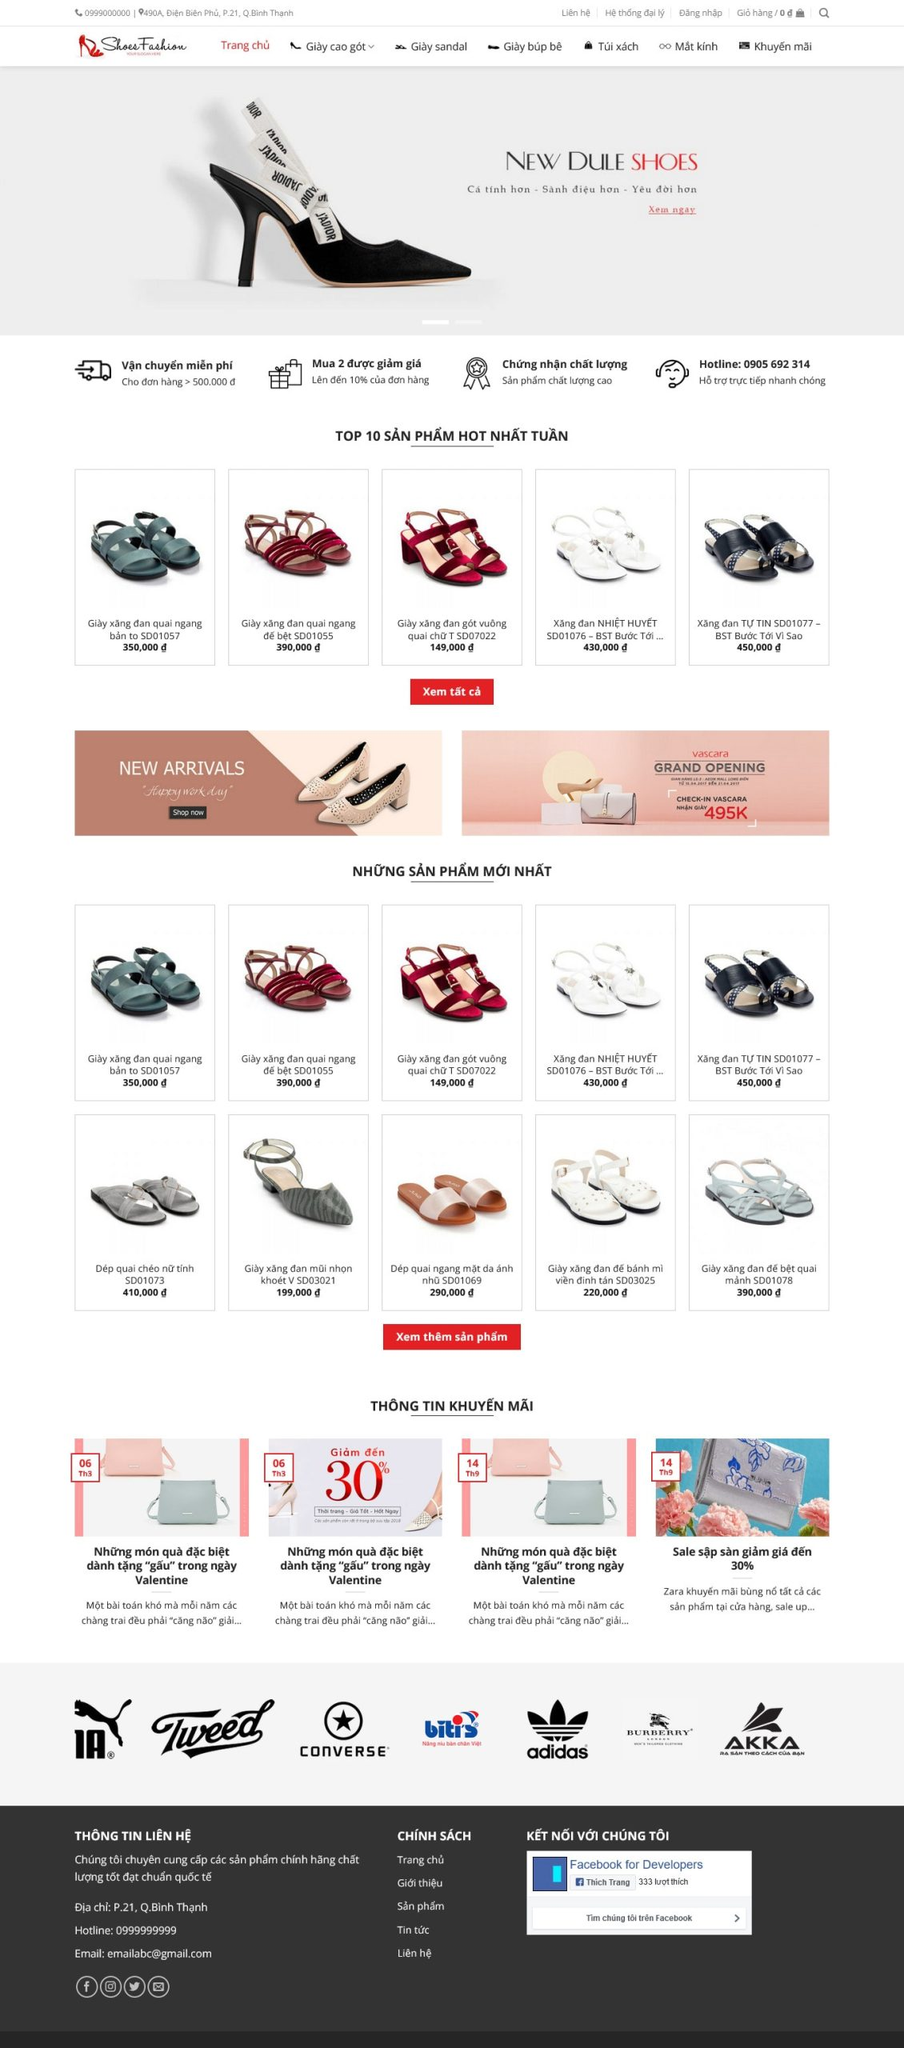Liệt kê 5 ngành nghề, lĩnh vực phù hợp với website này, phân cách các màu sắc bằng dấu phẩy. Chỉ trả về kết quả, phân cách bằng dấy phẩy
 Thời trang, Giày dép, Phụ kiện, Bán lẻ, Thương mại điện tử 